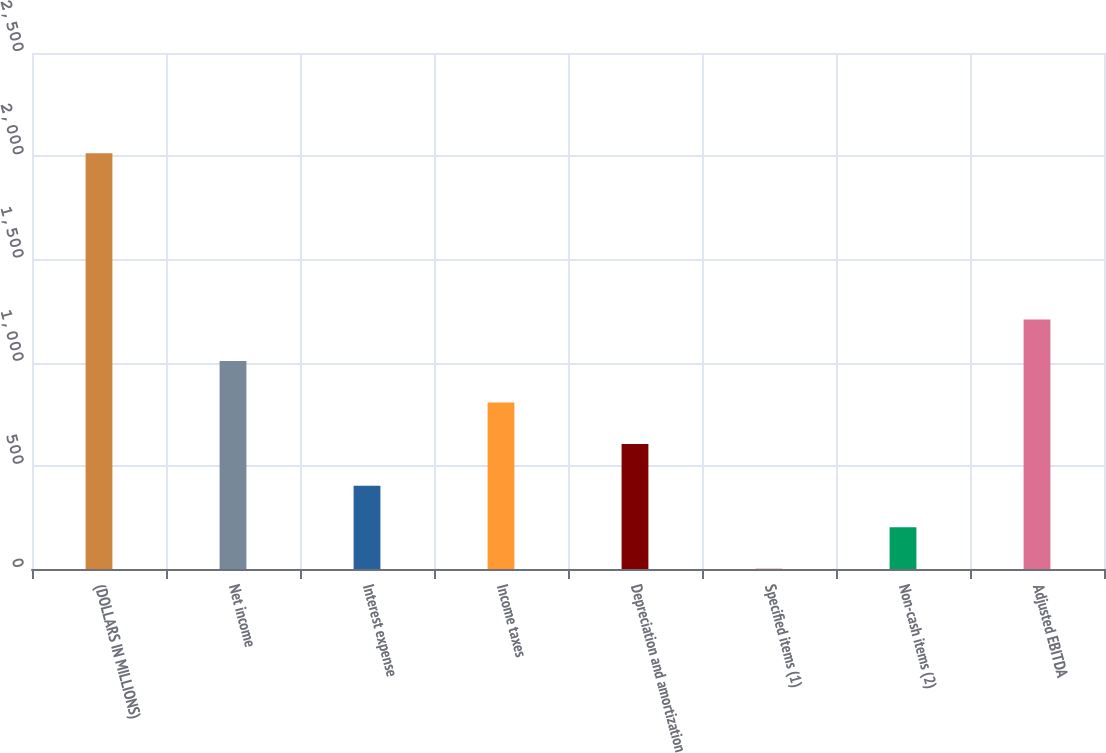Convert chart. <chart><loc_0><loc_0><loc_500><loc_500><bar_chart><fcel>(DOLLARS IN MILLIONS)<fcel>Net income<fcel>Interest expense<fcel>Income taxes<fcel>Depreciation and amortization<fcel>Specified items (1)<fcel>Non-cash items (2)<fcel>Adjusted EBITDA<nl><fcel>2014<fcel>1007.65<fcel>403.84<fcel>806.38<fcel>605.11<fcel>1.3<fcel>202.57<fcel>1208.92<nl></chart> 